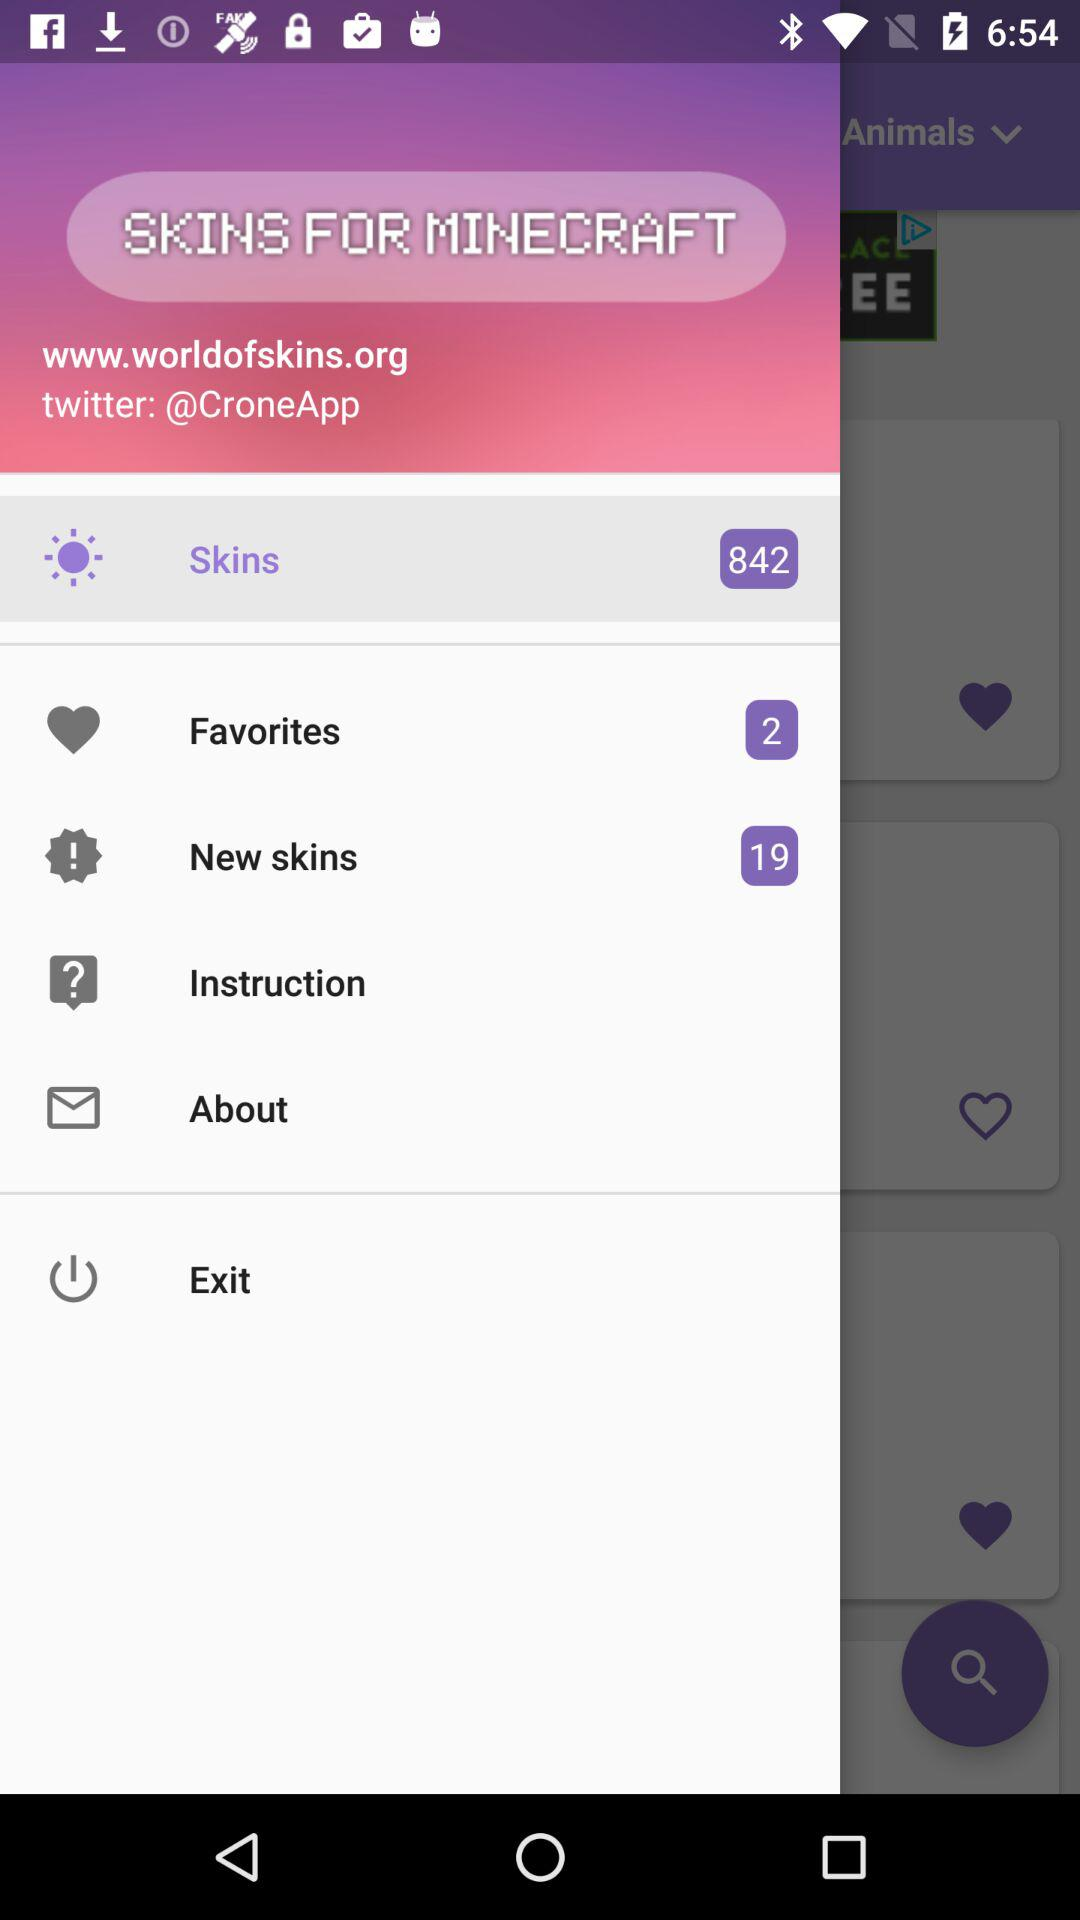How many items are there in "Skins"? There are 842 items in "Skins". 